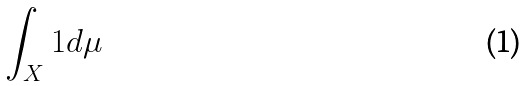Convert formula to latex. <formula><loc_0><loc_0><loc_500><loc_500>\int _ { X } 1 d \mu</formula> 